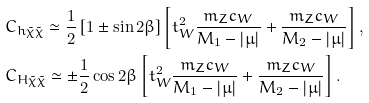Convert formula to latex. <formula><loc_0><loc_0><loc_500><loc_500>& C _ { h \tilde { \chi } \tilde { \chi } } \simeq \frac { 1 } { 2 } \left [ 1 \pm \sin 2 \beta \right ] \left [ t _ { W } ^ { 2 } \frac { m _ { Z } c _ { W } } { M _ { 1 } - | \mu | } + \frac { m _ { Z } c _ { W } } { M _ { 2 } - | \mu | } \right ] , \\ & C _ { H \tilde { \chi } \tilde { \chi } } \simeq \pm \frac { 1 } { 2 } \cos 2 \beta \left [ t _ { W } ^ { 2 } \frac { m _ { Z } c _ { W } } { M _ { 1 } - | \mu | } + \frac { m _ { Z } c _ { W } } { M _ { 2 } - | \mu | } \right ] .</formula> 